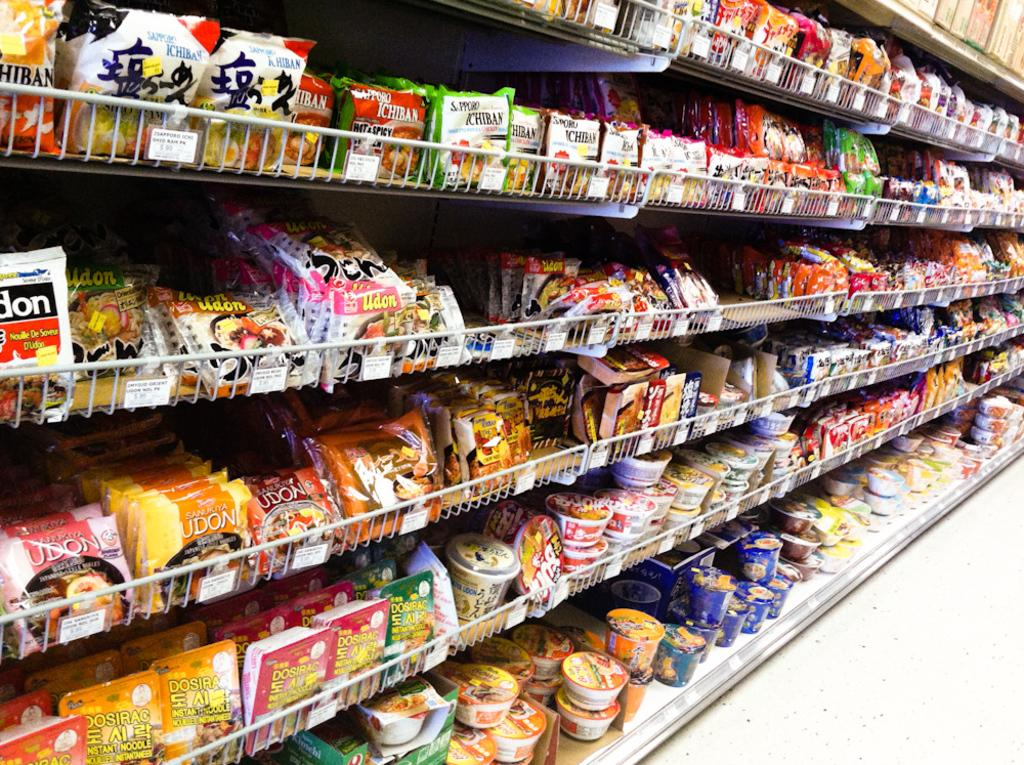<image>
Summarize the visual content of the image. a display of instant food including some by ICHIBAN line shelves 